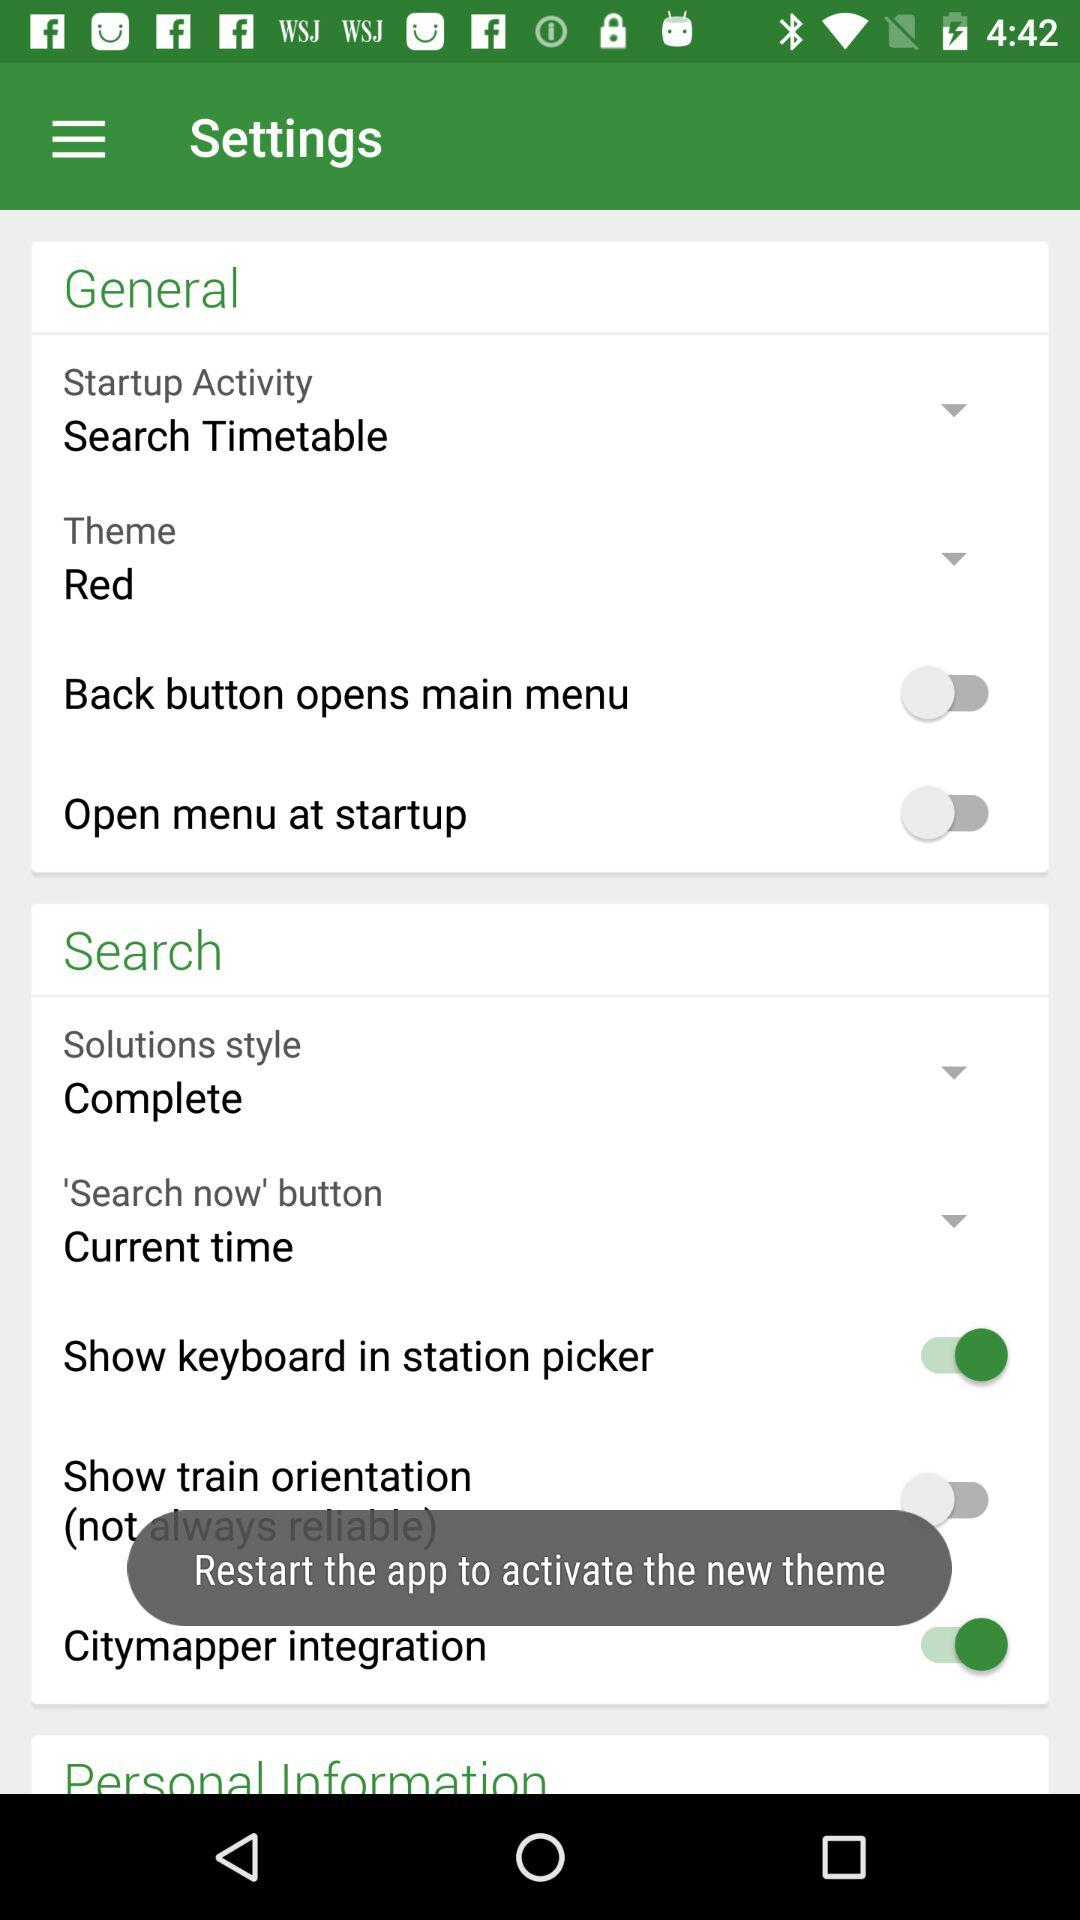What is the setting for "Show keyboard in station picker"? The setting for "Show keyboard in station picker" is "on". 